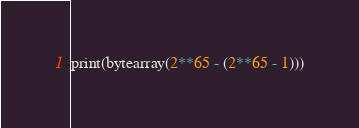Convert code to text. <code><loc_0><loc_0><loc_500><loc_500><_Python_>print(bytearray(2**65 - (2**65 - 1)))
</code> 